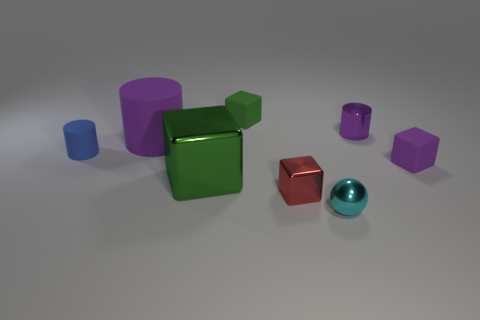What number of blue matte objects are the same shape as the tiny purple matte object? There are two blue matte objects that match the shape of the tiny purple matte object, which are the cylinder and the cube. 